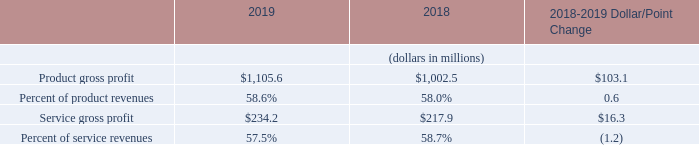The breakout of product and service gross profit was as follows:
We assess the carrying value of our inventory on a quarterly basis by estimating future demand and comparing that demand against on-hand and on-order inventory positions. Forecasted revenues information is obtained from the sales and marketing groups and incorporates factors such as backlog and future consolidated revenues. This quarterly process identifies obsolete and excess inventory. Obsolete inventory, which represents items for which there is no demand, is fully reserved. Excess inventory, which represents inventory items that are not expected to be consumed during the next twelve quarters for our Semiconductor Test, Industrial Automation and System Test segments and next four quarters for our Wireless Test segment, is written-down to estimated net realizable value.
During the year ended December 31, 2019, we recorded an inventory provision of $15.2 million included in cost of revenues, primarily due to downward revisions to previously forecasted demand levels for certain products. Of the $15.2 million of total excess and obsolete provisions, $8.7 million was related to Semiconductor Test, $4.0 million was related to Wireless Test, $2.0 million was related to System Test, and $0.5 million was related to Industrial Automation.
During the year ended December 31, 2018, we recorded an inventory provision of $11.2 million included in cost of revenues, primarily due to downward revisions to previously forecasted demand levels for certain products. Of the $11.2 million of total excess and obsolete provisions, $6.8 million was related to Semiconductor Test, $2.5 million was related to Wireless Test, $1.2 million was related to System Test, and $0.7 million was related to Industrial Automation.
During the years ended December 31, 2019 and 2018, we scrapped $9.2 million and $7.0 million of inventory, respectively, and sold $3.2 million and $6.7 million of previously written-down or written-off inventory, respectively. As of December 31, 2019, we had inventory related reserves for amounts which had been written-down or written-off totaling $103.6 million. We have no pre-determined timeline to scrap the remaining inventory.
How is the carrying value of inventory assessed? On a quarterly basis by estimating future demand and comparing that demand against on-hand and on-order inventory positions. What are the types of gross profit in the table? Product gross profit, service gross profit. In which years was the  breakout of product and service gross profit provided? 2019, 2018. In which year was service gross profit larger? 234.2>217.9
Answer: 2019. What was the percentage change in service gross profit from 2018 to 2019?
Answer scale should be: percent. (234.2-217.9)/217.9
Answer: 7.48. What was the percentage change in product gross profit from 2018 to 2019?
Answer scale should be: percent. (1,105.6-1,002.5)/1,002.5
Answer: 10.28. 